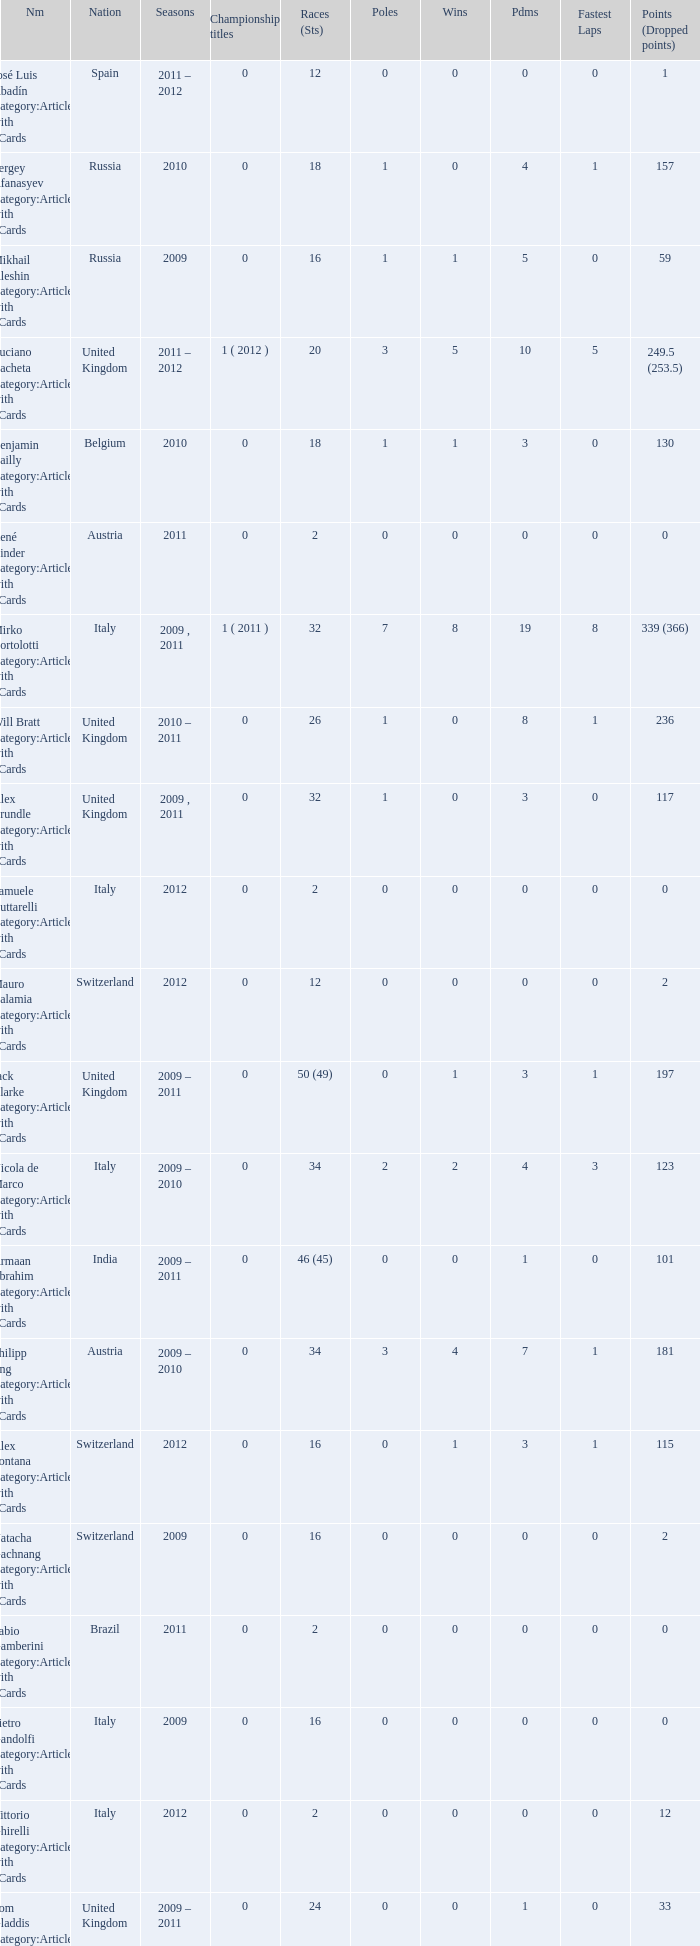What is the minimum amount of poles? 0.0. 